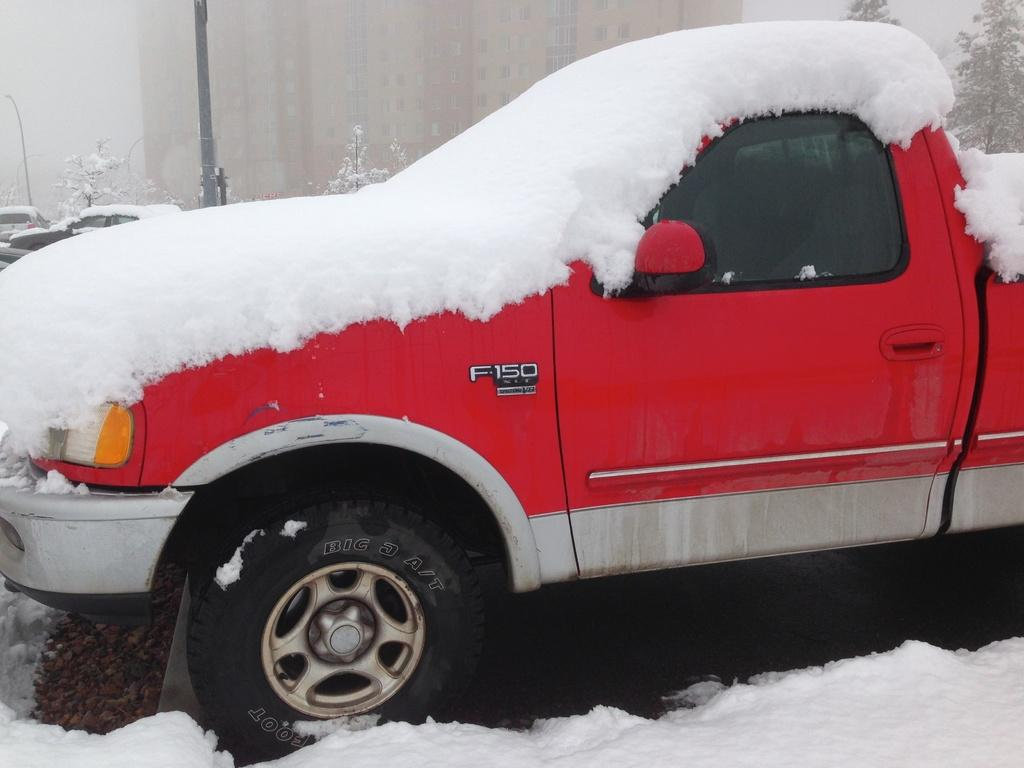Provide a one-sentence caption for the provided image. An F-150 red pick up truck covered in snow. 